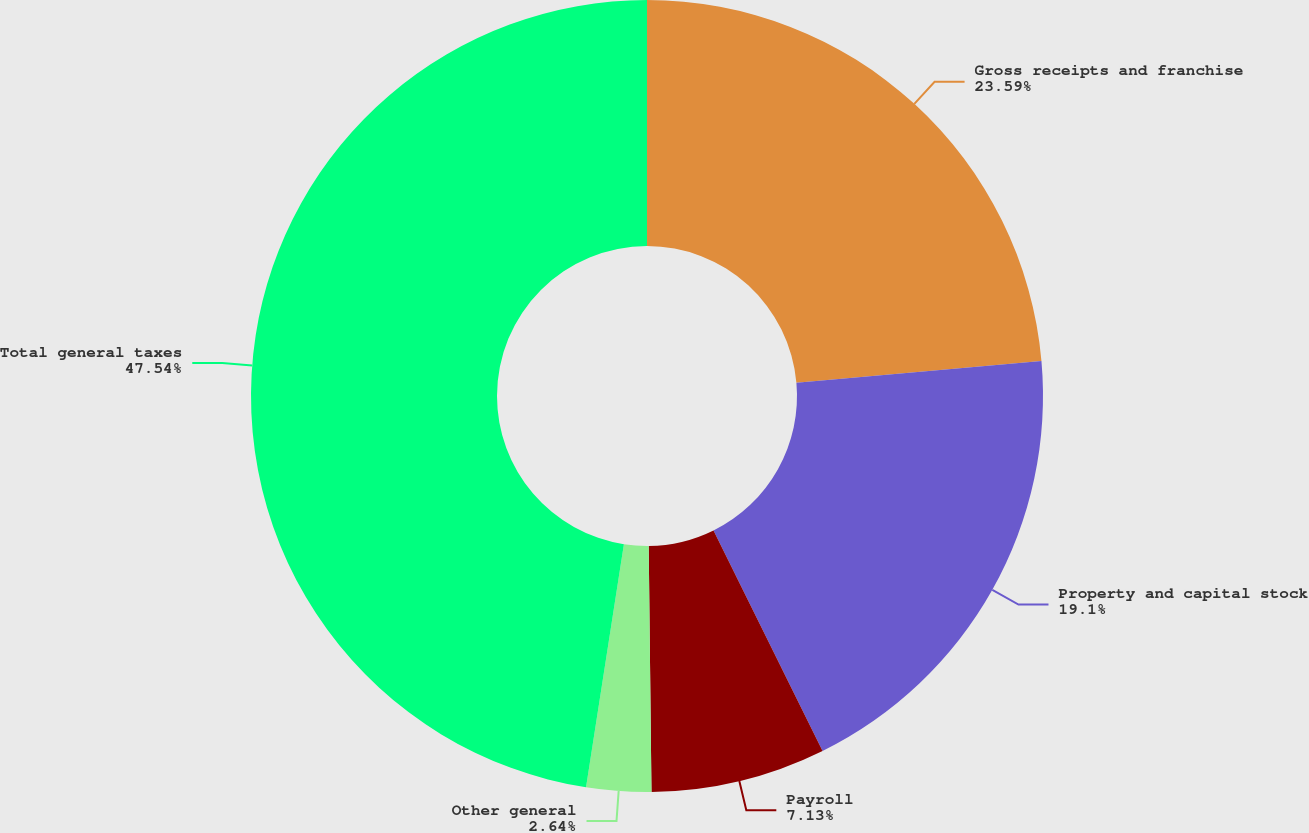Convert chart to OTSL. <chart><loc_0><loc_0><loc_500><loc_500><pie_chart><fcel>Gross receipts and franchise<fcel>Property and capital stock<fcel>Payroll<fcel>Other general<fcel>Total general taxes<nl><fcel>23.59%<fcel>19.1%<fcel>7.13%<fcel>2.64%<fcel>47.54%<nl></chart> 